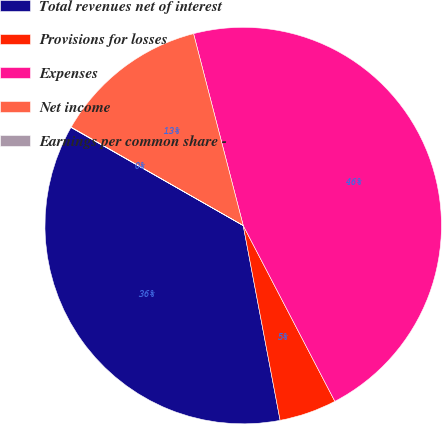Convert chart. <chart><loc_0><loc_0><loc_500><loc_500><pie_chart><fcel>Total revenues net of interest<fcel>Provisions for losses<fcel>Expenses<fcel>Net income<fcel>Earnings per common share -<nl><fcel>36.22%<fcel>4.67%<fcel>46.38%<fcel>12.7%<fcel>0.03%<nl></chart> 